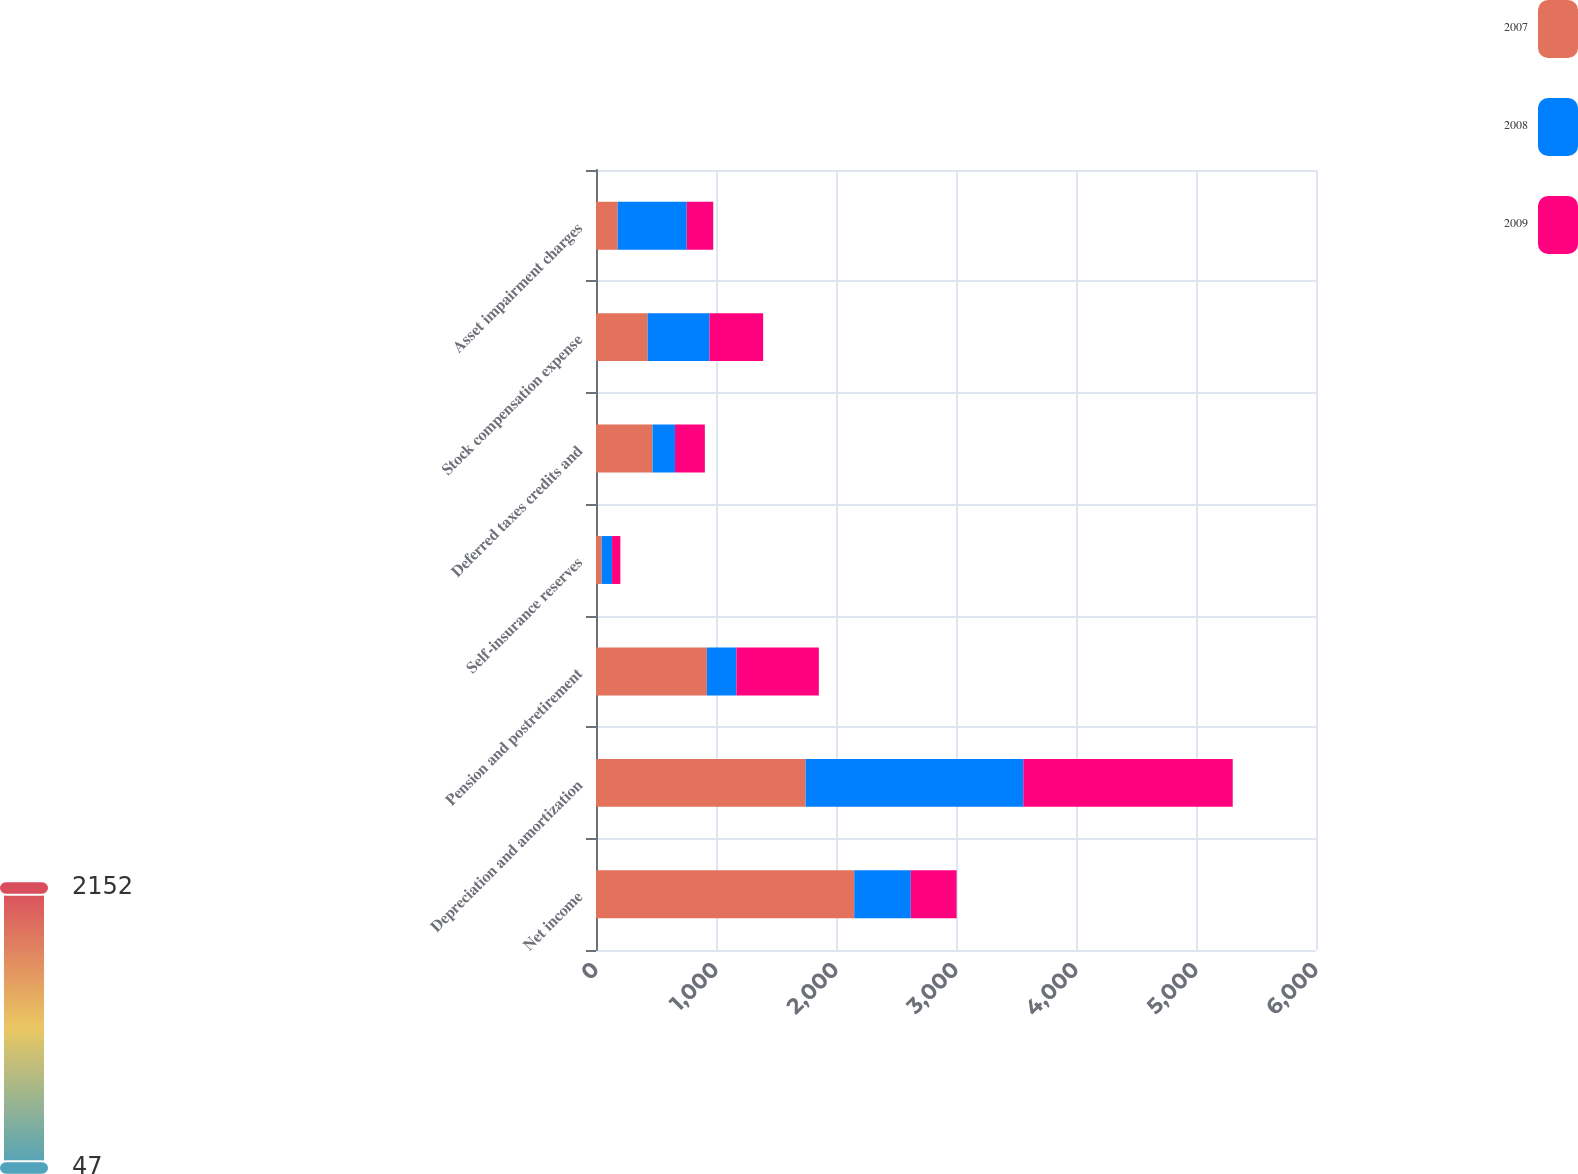Convert chart to OTSL. <chart><loc_0><loc_0><loc_500><loc_500><stacked_bar_chart><ecel><fcel>Net income<fcel>Depreciation and amortization<fcel>Pension and postretirement<fcel>Self-insurance reserves<fcel>Deferred taxes credits and<fcel>Stock compensation expense<fcel>Asset impairment charges<nl><fcel>2007<fcel>2152<fcel>1747<fcel>924<fcel>47<fcel>471<fcel>430<fcel>181<nl><fcel>2008<fcel>471<fcel>1814<fcel>246<fcel>87<fcel>187<fcel>516<fcel>575<nl><fcel>2009<fcel>382<fcel>1745<fcel>687<fcel>69<fcel>249<fcel>447<fcel>221<nl></chart> 